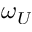<formula> <loc_0><loc_0><loc_500><loc_500>\omega _ { U }</formula> 